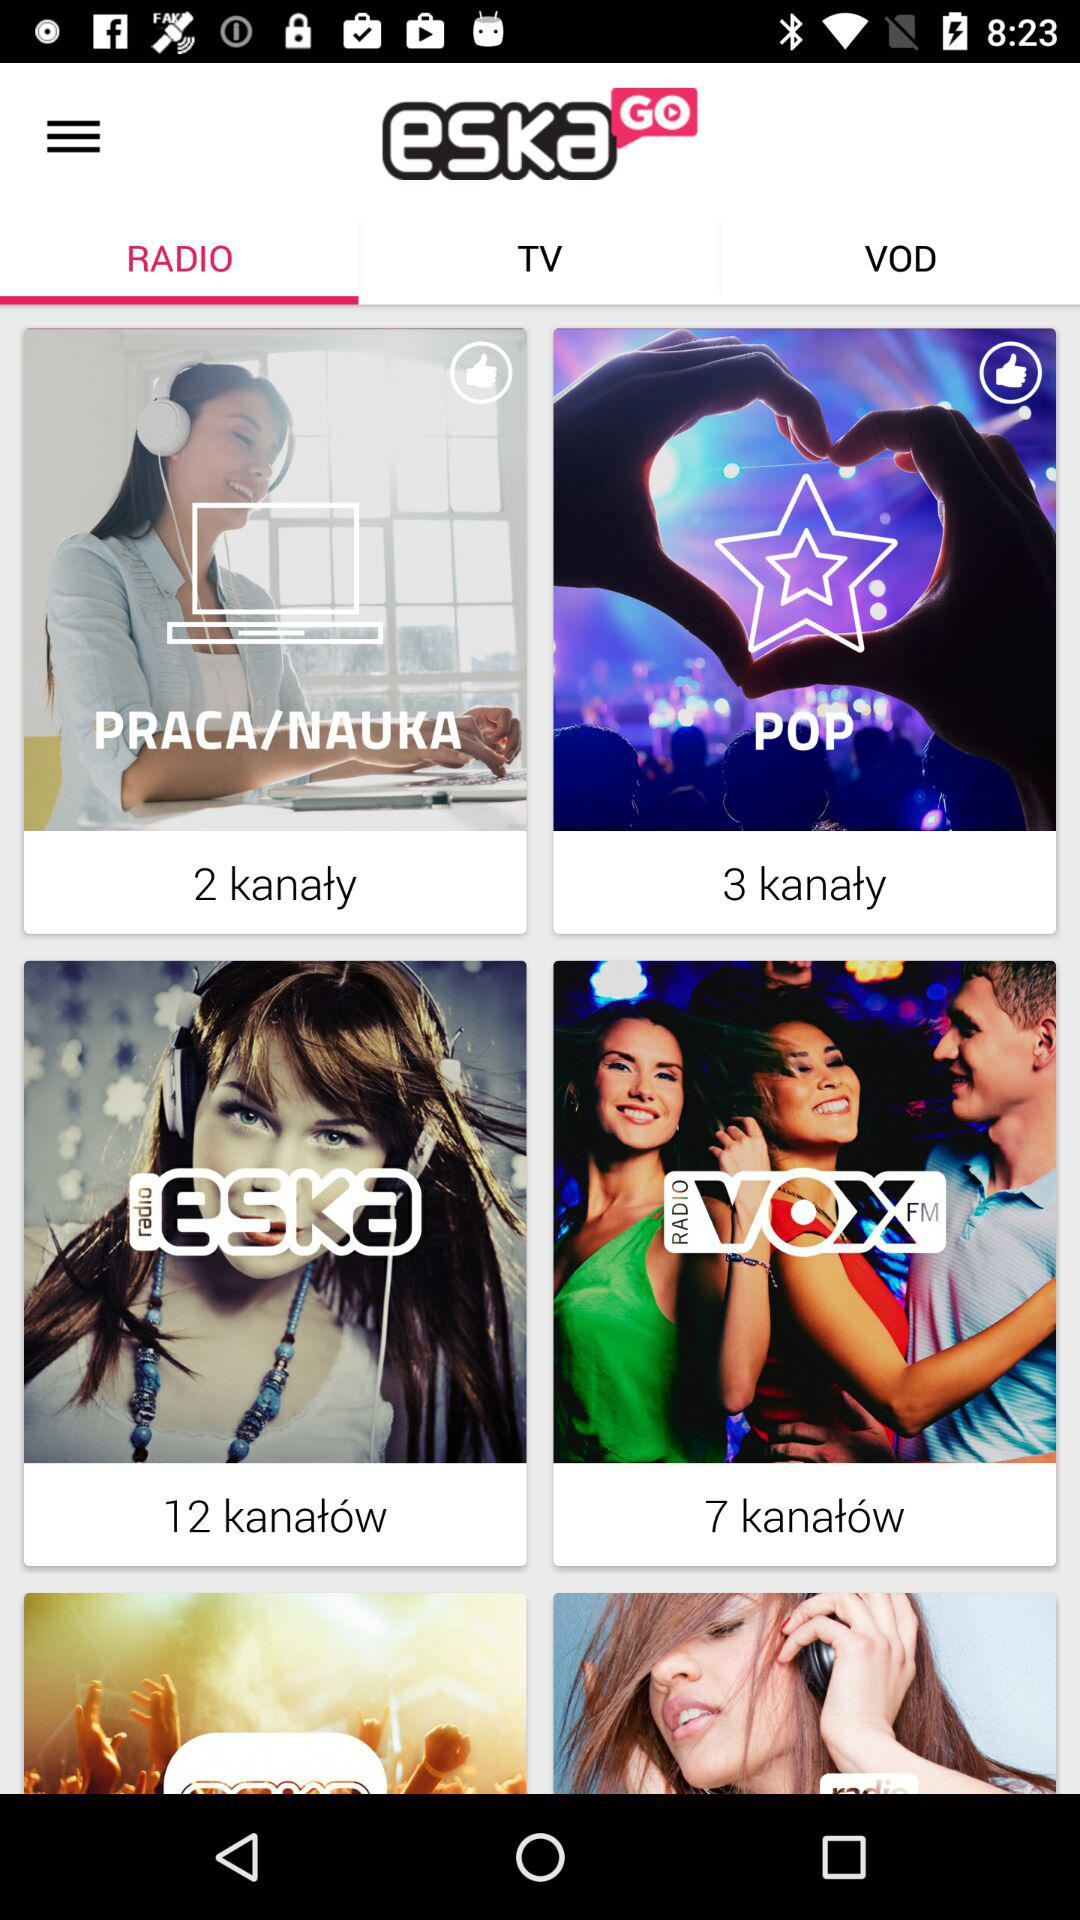How many more channels are there in the 'POP' category than the 'PRACA/NAUKA' category?
Answer the question using a single word or phrase. 1 